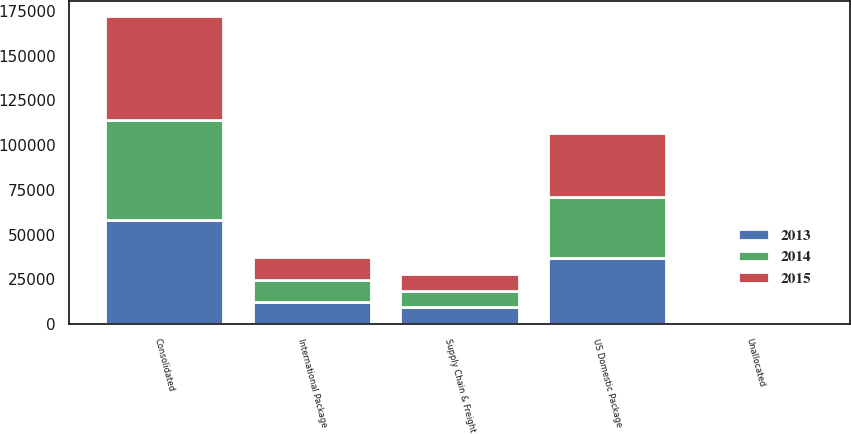Convert chart. <chart><loc_0><loc_0><loc_500><loc_500><stacked_bar_chart><ecel><fcel>US Domestic Package<fcel>International Package<fcel>Supply Chain & Freight<fcel>Consolidated<fcel>Unallocated<nl><fcel>2013<fcel>36747<fcel>12149<fcel>9467<fcel>58363<fcel>1024<nl><fcel>2015<fcel>35851<fcel>12988<fcel>9393<fcel>58232<fcel>878<nl><fcel>2014<fcel>34074<fcel>12429<fcel>8935<fcel>55438<fcel>1477<nl></chart> 